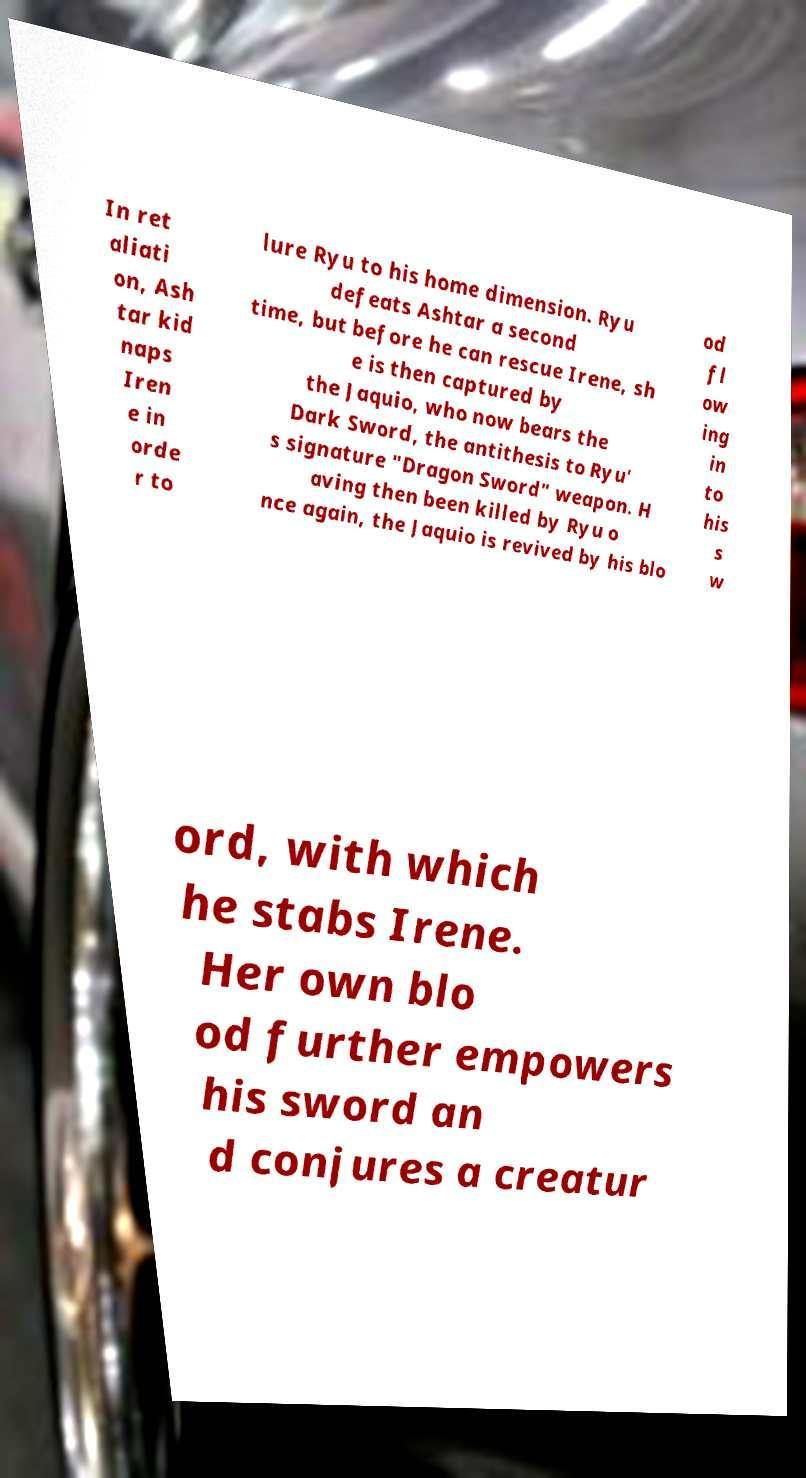Can you read and provide the text displayed in the image?This photo seems to have some interesting text. Can you extract and type it out for me? In ret aliati on, Ash tar kid naps Iren e in orde r to lure Ryu to his home dimension. Ryu defeats Ashtar a second time, but before he can rescue Irene, sh e is then captured by the Jaquio, who now bears the Dark Sword, the antithesis to Ryu' s signature "Dragon Sword" weapon. H aving then been killed by Ryu o nce again, the Jaquio is revived by his blo od fl ow ing in to his s w ord, with which he stabs Irene. Her own blo od further empowers his sword an d conjures a creatur 